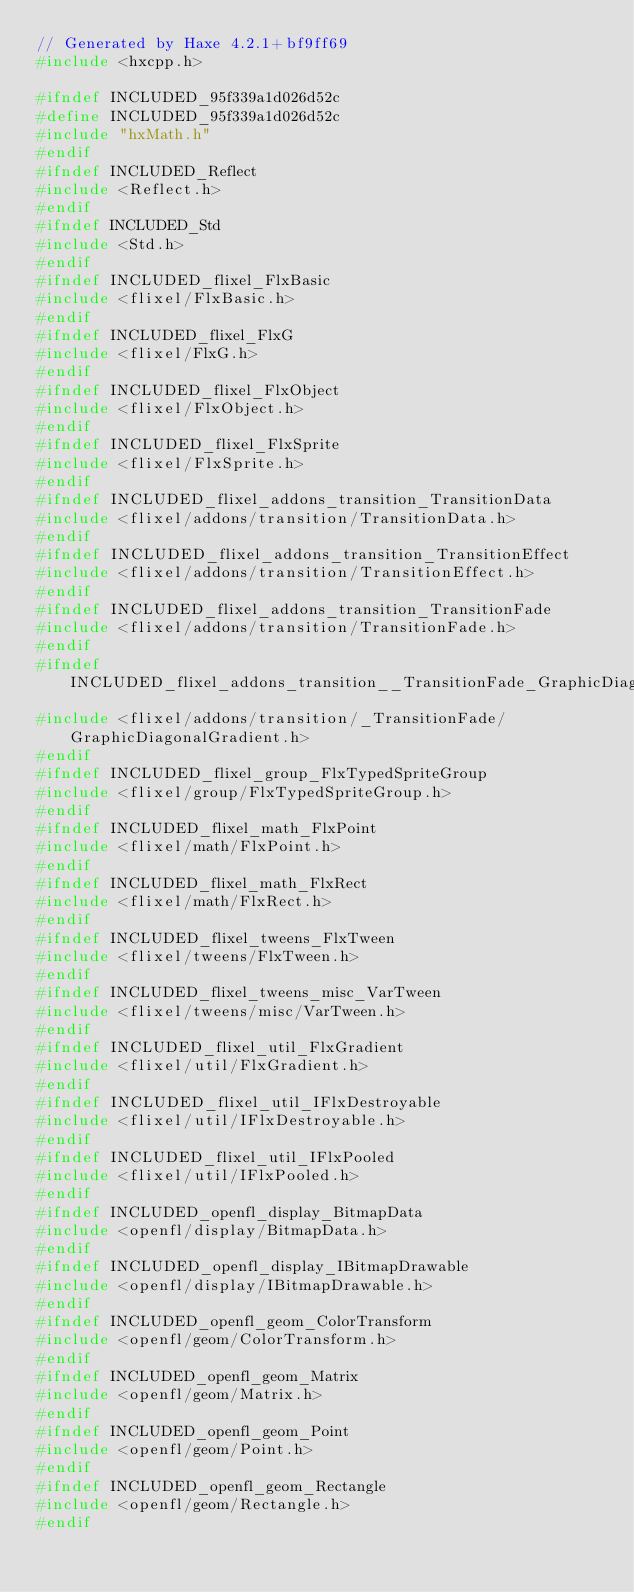Convert code to text. <code><loc_0><loc_0><loc_500><loc_500><_C++_>// Generated by Haxe 4.2.1+bf9ff69
#include <hxcpp.h>

#ifndef INCLUDED_95f339a1d026d52c
#define INCLUDED_95f339a1d026d52c
#include "hxMath.h"
#endif
#ifndef INCLUDED_Reflect
#include <Reflect.h>
#endif
#ifndef INCLUDED_Std
#include <Std.h>
#endif
#ifndef INCLUDED_flixel_FlxBasic
#include <flixel/FlxBasic.h>
#endif
#ifndef INCLUDED_flixel_FlxG
#include <flixel/FlxG.h>
#endif
#ifndef INCLUDED_flixel_FlxObject
#include <flixel/FlxObject.h>
#endif
#ifndef INCLUDED_flixel_FlxSprite
#include <flixel/FlxSprite.h>
#endif
#ifndef INCLUDED_flixel_addons_transition_TransitionData
#include <flixel/addons/transition/TransitionData.h>
#endif
#ifndef INCLUDED_flixel_addons_transition_TransitionEffect
#include <flixel/addons/transition/TransitionEffect.h>
#endif
#ifndef INCLUDED_flixel_addons_transition_TransitionFade
#include <flixel/addons/transition/TransitionFade.h>
#endif
#ifndef INCLUDED_flixel_addons_transition__TransitionFade_GraphicDiagonalGradient
#include <flixel/addons/transition/_TransitionFade/GraphicDiagonalGradient.h>
#endif
#ifndef INCLUDED_flixel_group_FlxTypedSpriteGroup
#include <flixel/group/FlxTypedSpriteGroup.h>
#endif
#ifndef INCLUDED_flixel_math_FlxPoint
#include <flixel/math/FlxPoint.h>
#endif
#ifndef INCLUDED_flixel_math_FlxRect
#include <flixel/math/FlxRect.h>
#endif
#ifndef INCLUDED_flixel_tweens_FlxTween
#include <flixel/tweens/FlxTween.h>
#endif
#ifndef INCLUDED_flixel_tweens_misc_VarTween
#include <flixel/tweens/misc/VarTween.h>
#endif
#ifndef INCLUDED_flixel_util_FlxGradient
#include <flixel/util/FlxGradient.h>
#endif
#ifndef INCLUDED_flixel_util_IFlxDestroyable
#include <flixel/util/IFlxDestroyable.h>
#endif
#ifndef INCLUDED_flixel_util_IFlxPooled
#include <flixel/util/IFlxPooled.h>
#endif
#ifndef INCLUDED_openfl_display_BitmapData
#include <openfl/display/BitmapData.h>
#endif
#ifndef INCLUDED_openfl_display_IBitmapDrawable
#include <openfl/display/IBitmapDrawable.h>
#endif
#ifndef INCLUDED_openfl_geom_ColorTransform
#include <openfl/geom/ColorTransform.h>
#endif
#ifndef INCLUDED_openfl_geom_Matrix
#include <openfl/geom/Matrix.h>
#endif
#ifndef INCLUDED_openfl_geom_Point
#include <openfl/geom/Point.h>
#endif
#ifndef INCLUDED_openfl_geom_Rectangle
#include <openfl/geom/Rectangle.h>
#endif
</code> 